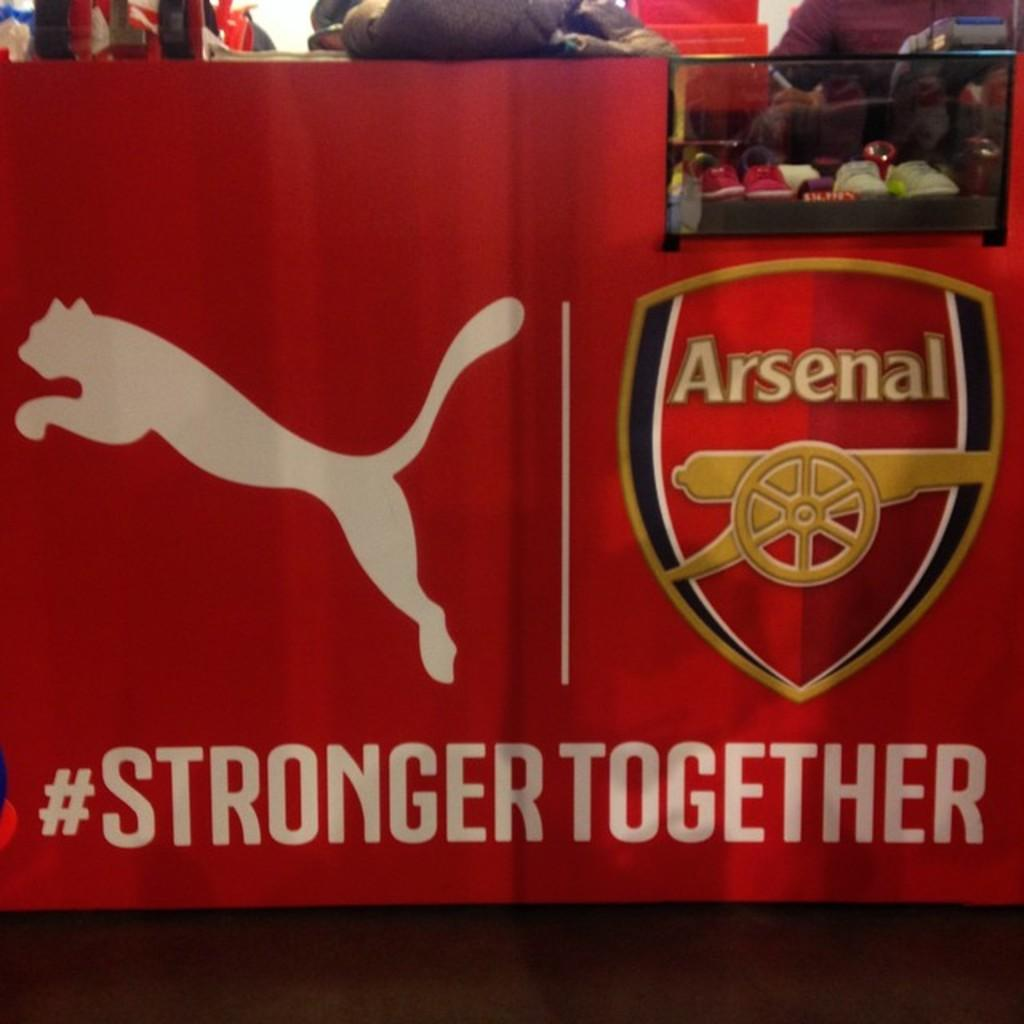<image>
Offer a succinct explanation of the picture presented. A Puma advertisement in the UK for Arsenal, a soccer team, with the hastag #STRONGERTOGETHER. 